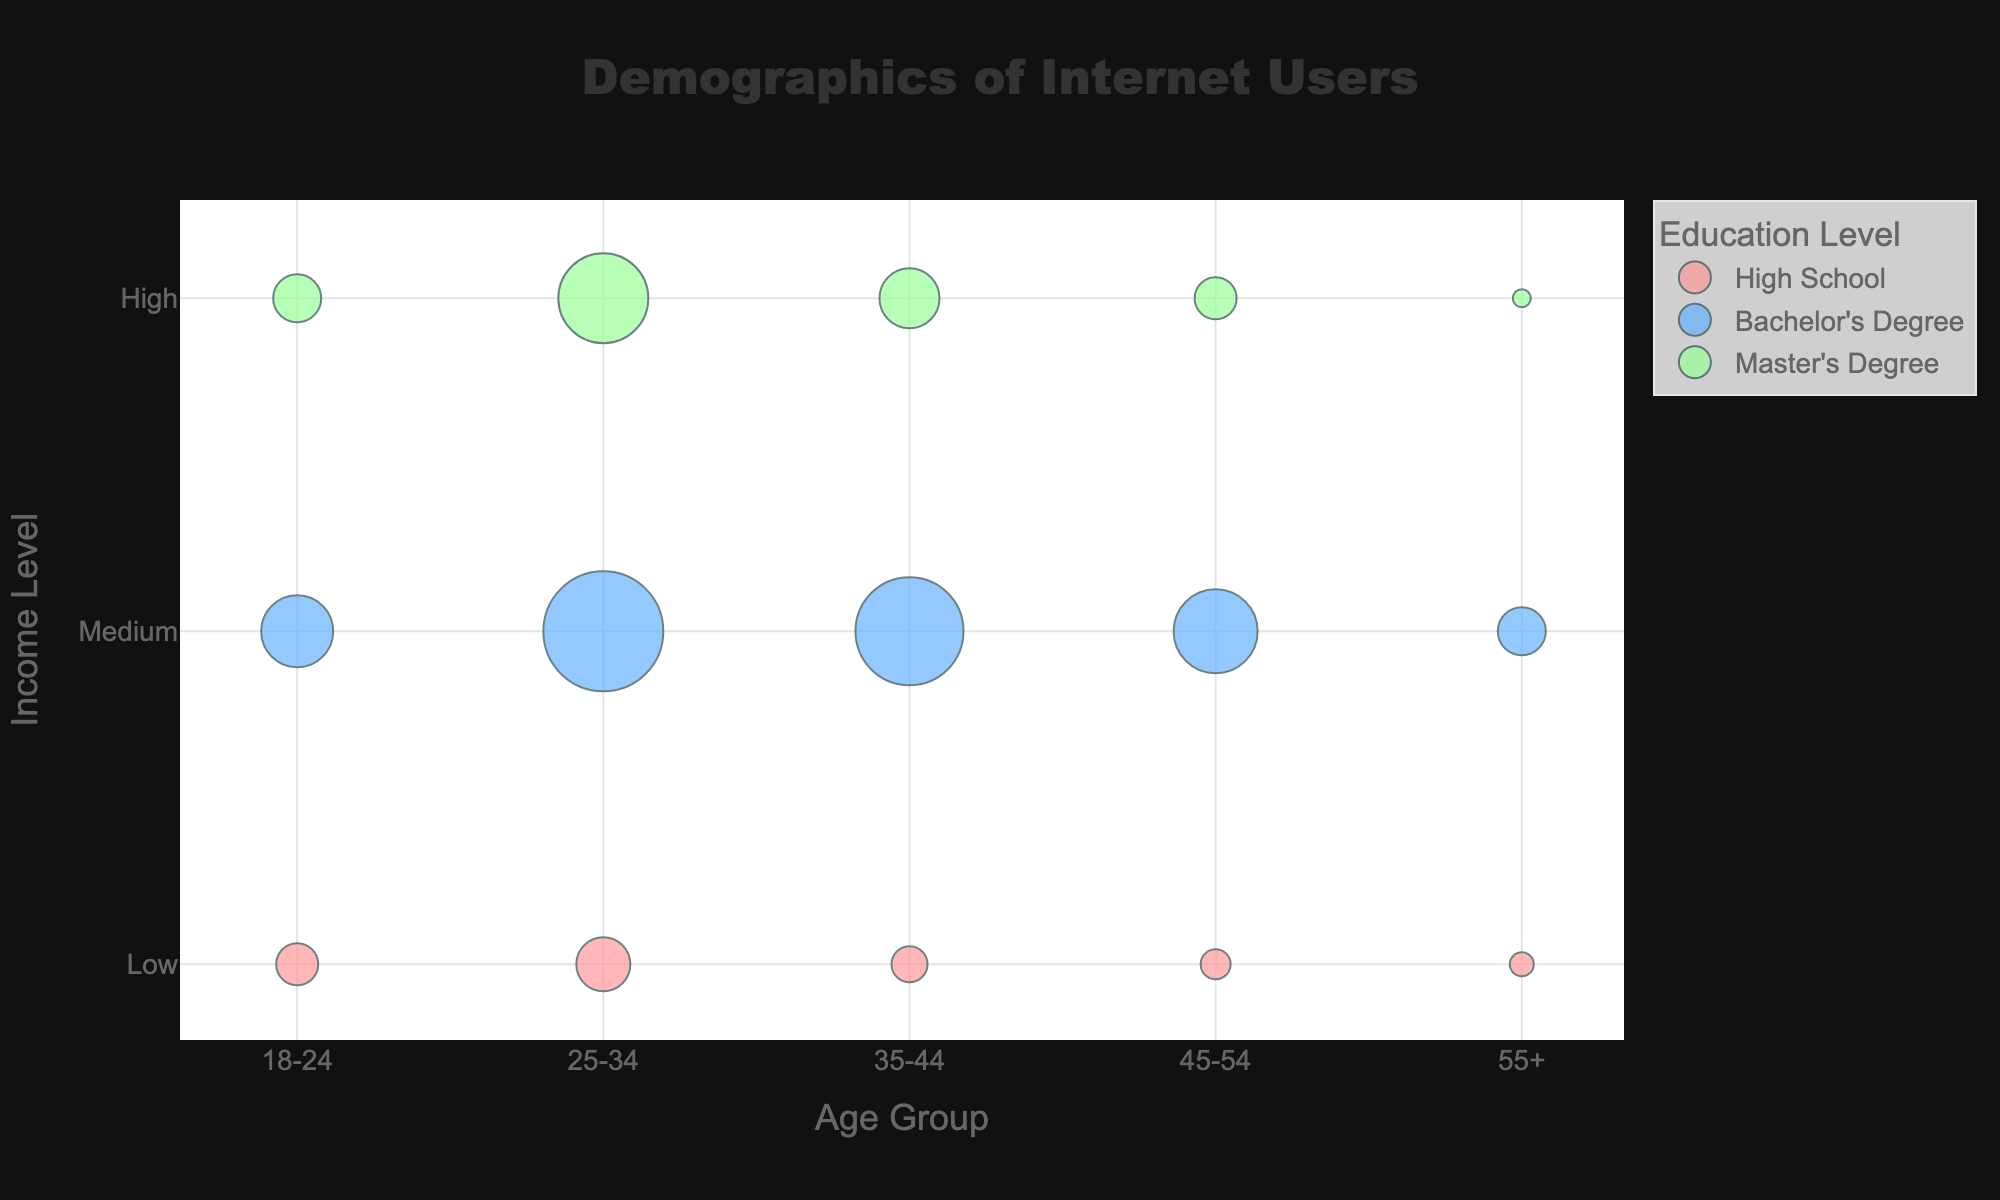What is the title of the plot? The title is written at the top and center of the plot, and it reads: "Demographics of Internet Users".
Answer: Demographics of Internet Users Which age group with a Bachelor's Degree has the highest percentage of users? Look at the bubbles corresponding to the "Bachelor's Degree" category. Observe their sizes across the age groups. The 25-34 age group has the largest bubble among them.
Answer: 25-34 What income level has the highest percentage of internet users in the age group 35-44? Examine the bubbles in the age group 35-44. Compare the sizes of bubbles at different income levels within this age group. The bubble for the "Medium" income level is the largest.
Answer: Medium How many distinct age groups are shown in the plot? Count how many different age group labels are present on the x-axis: 18-24, 25-34, 35-44, 45-54, and 55+.
Answer: 5 Which age group, income level, and education level combination has the smallest bubble size in the plot? Scan through each age group, income level, and education level combination, looking for the smallest bubble. The smallest bubble is for age group 55+, income level High, and education level Master's Degree.
Answer: 55+, High, Master's Degree Which age group has the lowest percentage of users with high school education overall? Look for "High School" bubbles in each age group and compare their sizes. The age group 55+ has the smallest bubble for high school education.
Answer: 55+ Compare the percentage of users with a Master's Degree between age groups 18-24 and 45-54 within the High income level, which is higher? Find and compare the sizes of the bubbles for Master's Degree in the High income level for age groups 18-24 and 45-54. The bubble for age group 18-24 is larger.
Answer: Age group 18-24 Which educational level has more diverse user percentages across different age groups? Observe the spread and sizes of bubbles for each education level across different age groups. The Bachelor's Degree level has more varied bubble sizes.
Answer: Bachelor's Degree What is the average percentage of users across all age groups with a Medium income level? Sum the percentages for Medium income across all age groups (12 + 20 + 18 + 14 + 8) = 72, then divide by the number of age groups (5).
Answer: 14.4% How does the percentage of users with a high school education in the 18-24 age group compare to those in the 45-54 age group? Compare the size of the bubbles for high school education between these two age groups. The bubble for age group 18-24 is slightly larger than the bubble for age group 45-54.
Answer: 18-24 is higher 